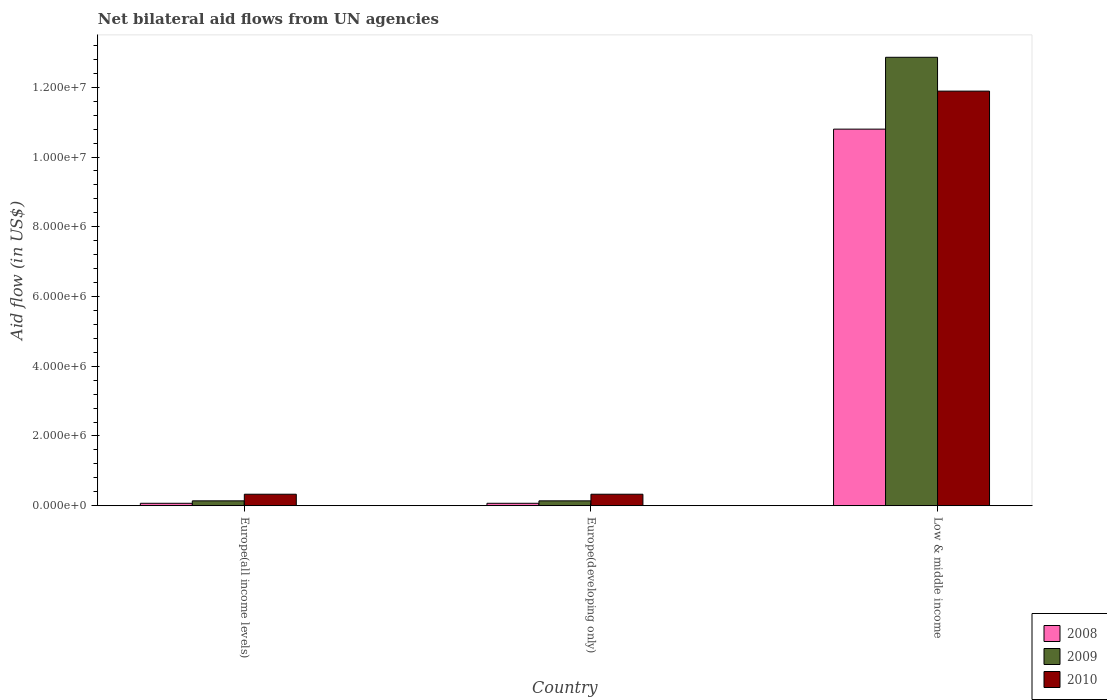Are the number of bars per tick equal to the number of legend labels?
Offer a terse response. Yes. Are the number of bars on each tick of the X-axis equal?
Your answer should be very brief. Yes. How many bars are there on the 2nd tick from the right?
Ensure brevity in your answer.  3. What is the label of the 2nd group of bars from the left?
Keep it short and to the point. Europe(developing only). What is the net bilateral aid flow in 2008 in Low & middle income?
Your answer should be compact. 1.08e+07. Across all countries, what is the maximum net bilateral aid flow in 2010?
Make the answer very short. 1.19e+07. Across all countries, what is the minimum net bilateral aid flow in 2008?
Offer a terse response. 7.00e+04. In which country was the net bilateral aid flow in 2008 minimum?
Provide a short and direct response. Europe(all income levels). What is the total net bilateral aid flow in 2009 in the graph?
Give a very brief answer. 1.31e+07. What is the difference between the net bilateral aid flow in 2009 in Europe(all income levels) and that in Low & middle income?
Provide a succinct answer. -1.27e+07. What is the difference between the net bilateral aid flow in 2010 in Low & middle income and the net bilateral aid flow in 2009 in Europe(all income levels)?
Your answer should be very brief. 1.18e+07. What is the average net bilateral aid flow in 2009 per country?
Your response must be concise. 4.38e+06. What is the difference between the net bilateral aid flow of/in 2009 and net bilateral aid flow of/in 2010 in Low & middle income?
Offer a very short reply. 9.70e+05. In how many countries, is the net bilateral aid flow in 2008 greater than 4400000 US$?
Provide a short and direct response. 1. What is the ratio of the net bilateral aid flow in 2010 in Europe(all income levels) to that in Low & middle income?
Keep it short and to the point. 0.03. Is the net bilateral aid flow in 2008 in Europe(developing only) less than that in Low & middle income?
Make the answer very short. Yes. Is the difference between the net bilateral aid flow in 2009 in Europe(all income levels) and Europe(developing only) greater than the difference between the net bilateral aid flow in 2010 in Europe(all income levels) and Europe(developing only)?
Your response must be concise. No. What is the difference between the highest and the second highest net bilateral aid flow in 2010?
Provide a succinct answer. 1.16e+07. What is the difference between the highest and the lowest net bilateral aid flow in 2008?
Offer a terse response. 1.07e+07. How many countries are there in the graph?
Offer a very short reply. 3. What is the difference between two consecutive major ticks on the Y-axis?
Make the answer very short. 2.00e+06. Are the values on the major ticks of Y-axis written in scientific E-notation?
Your response must be concise. Yes. Where does the legend appear in the graph?
Your response must be concise. Bottom right. What is the title of the graph?
Keep it short and to the point. Net bilateral aid flows from UN agencies. Does "1998" appear as one of the legend labels in the graph?
Offer a terse response. No. What is the label or title of the X-axis?
Provide a short and direct response. Country. What is the label or title of the Y-axis?
Offer a terse response. Aid flow (in US$). What is the Aid flow (in US$) in 2008 in Europe(all income levels)?
Give a very brief answer. 7.00e+04. What is the Aid flow (in US$) of 2009 in Europe(all income levels)?
Your answer should be compact. 1.40e+05. What is the Aid flow (in US$) in 2010 in Europe(all income levels)?
Give a very brief answer. 3.30e+05. What is the Aid flow (in US$) in 2008 in Europe(developing only)?
Ensure brevity in your answer.  7.00e+04. What is the Aid flow (in US$) of 2008 in Low & middle income?
Your response must be concise. 1.08e+07. What is the Aid flow (in US$) of 2009 in Low & middle income?
Offer a very short reply. 1.29e+07. What is the Aid flow (in US$) of 2010 in Low & middle income?
Offer a very short reply. 1.19e+07. Across all countries, what is the maximum Aid flow (in US$) in 2008?
Make the answer very short. 1.08e+07. Across all countries, what is the maximum Aid flow (in US$) of 2009?
Your response must be concise. 1.29e+07. Across all countries, what is the maximum Aid flow (in US$) in 2010?
Your answer should be compact. 1.19e+07. Across all countries, what is the minimum Aid flow (in US$) of 2008?
Offer a very short reply. 7.00e+04. What is the total Aid flow (in US$) in 2008 in the graph?
Keep it short and to the point. 1.09e+07. What is the total Aid flow (in US$) in 2009 in the graph?
Ensure brevity in your answer.  1.31e+07. What is the total Aid flow (in US$) of 2010 in the graph?
Provide a succinct answer. 1.26e+07. What is the difference between the Aid flow (in US$) of 2008 in Europe(all income levels) and that in Europe(developing only)?
Provide a short and direct response. 0. What is the difference between the Aid flow (in US$) of 2009 in Europe(all income levels) and that in Europe(developing only)?
Your response must be concise. 0. What is the difference between the Aid flow (in US$) in 2008 in Europe(all income levels) and that in Low & middle income?
Your response must be concise. -1.07e+07. What is the difference between the Aid flow (in US$) in 2009 in Europe(all income levels) and that in Low & middle income?
Make the answer very short. -1.27e+07. What is the difference between the Aid flow (in US$) of 2010 in Europe(all income levels) and that in Low & middle income?
Ensure brevity in your answer.  -1.16e+07. What is the difference between the Aid flow (in US$) in 2008 in Europe(developing only) and that in Low & middle income?
Provide a short and direct response. -1.07e+07. What is the difference between the Aid flow (in US$) of 2009 in Europe(developing only) and that in Low & middle income?
Your answer should be compact. -1.27e+07. What is the difference between the Aid flow (in US$) of 2010 in Europe(developing only) and that in Low & middle income?
Offer a terse response. -1.16e+07. What is the difference between the Aid flow (in US$) in 2008 in Europe(all income levels) and the Aid flow (in US$) in 2009 in Europe(developing only)?
Your answer should be compact. -7.00e+04. What is the difference between the Aid flow (in US$) in 2008 in Europe(all income levels) and the Aid flow (in US$) in 2010 in Europe(developing only)?
Provide a short and direct response. -2.60e+05. What is the difference between the Aid flow (in US$) of 2009 in Europe(all income levels) and the Aid flow (in US$) of 2010 in Europe(developing only)?
Your answer should be very brief. -1.90e+05. What is the difference between the Aid flow (in US$) of 2008 in Europe(all income levels) and the Aid flow (in US$) of 2009 in Low & middle income?
Give a very brief answer. -1.28e+07. What is the difference between the Aid flow (in US$) of 2008 in Europe(all income levels) and the Aid flow (in US$) of 2010 in Low & middle income?
Your response must be concise. -1.18e+07. What is the difference between the Aid flow (in US$) in 2009 in Europe(all income levels) and the Aid flow (in US$) in 2010 in Low & middle income?
Ensure brevity in your answer.  -1.18e+07. What is the difference between the Aid flow (in US$) of 2008 in Europe(developing only) and the Aid flow (in US$) of 2009 in Low & middle income?
Make the answer very short. -1.28e+07. What is the difference between the Aid flow (in US$) in 2008 in Europe(developing only) and the Aid flow (in US$) in 2010 in Low & middle income?
Make the answer very short. -1.18e+07. What is the difference between the Aid flow (in US$) in 2009 in Europe(developing only) and the Aid flow (in US$) in 2010 in Low & middle income?
Provide a short and direct response. -1.18e+07. What is the average Aid flow (in US$) in 2008 per country?
Offer a terse response. 3.65e+06. What is the average Aid flow (in US$) of 2009 per country?
Provide a short and direct response. 4.38e+06. What is the average Aid flow (in US$) in 2010 per country?
Offer a terse response. 4.18e+06. What is the difference between the Aid flow (in US$) in 2008 and Aid flow (in US$) in 2009 in Europe(all income levels)?
Ensure brevity in your answer.  -7.00e+04. What is the difference between the Aid flow (in US$) of 2008 and Aid flow (in US$) of 2010 in Europe(developing only)?
Your response must be concise. -2.60e+05. What is the difference between the Aid flow (in US$) in 2008 and Aid flow (in US$) in 2009 in Low & middle income?
Your answer should be very brief. -2.06e+06. What is the difference between the Aid flow (in US$) of 2008 and Aid flow (in US$) of 2010 in Low & middle income?
Make the answer very short. -1.09e+06. What is the difference between the Aid flow (in US$) in 2009 and Aid flow (in US$) in 2010 in Low & middle income?
Your answer should be very brief. 9.70e+05. What is the ratio of the Aid flow (in US$) of 2009 in Europe(all income levels) to that in Europe(developing only)?
Offer a very short reply. 1. What is the ratio of the Aid flow (in US$) in 2010 in Europe(all income levels) to that in Europe(developing only)?
Offer a terse response. 1. What is the ratio of the Aid flow (in US$) of 2008 in Europe(all income levels) to that in Low & middle income?
Make the answer very short. 0.01. What is the ratio of the Aid flow (in US$) in 2009 in Europe(all income levels) to that in Low & middle income?
Keep it short and to the point. 0.01. What is the ratio of the Aid flow (in US$) in 2010 in Europe(all income levels) to that in Low & middle income?
Keep it short and to the point. 0.03. What is the ratio of the Aid flow (in US$) in 2008 in Europe(developing only) to that in Low & middle income?
Keep it short and to the point. 0.01. What is the ratio of the Aid flow (in US$) in 2009 in Europe(developing only) to that in Low & middle income?
Offer a very short reply. 0.01. What is the ratio of the Aid flow (in US$) of 2010 in Europe(developing only) to that in Low & middle income?
Provide a succinct answer. 0.03. What is the difference between the highest and the second highest Aid flow (in US$) in 2008?
Provide a short and direct response. 1.07e+07. What is the difference between the highest and the second highest Aid flow (in US$) in 2009?
Keep it short and to the point. 1.27e+07. What is the difference between the highest and the second highest Aid flow (in US$) in 2010?
Offer a very short reply. 1.16e+07. What is the difference between the highest and the lowest Aid flow (in US$) of 2008?
Your response must be concise. 1.07e+07. What is the difference between the highest and the lowest Aid flow (in US$) in 2009?
Your response must be concise. 1.27e+07. What is the difference between the highest and the lowest Aid flow (in US$) of 2010?
Provide a short and direct response. 1.16e+07. 